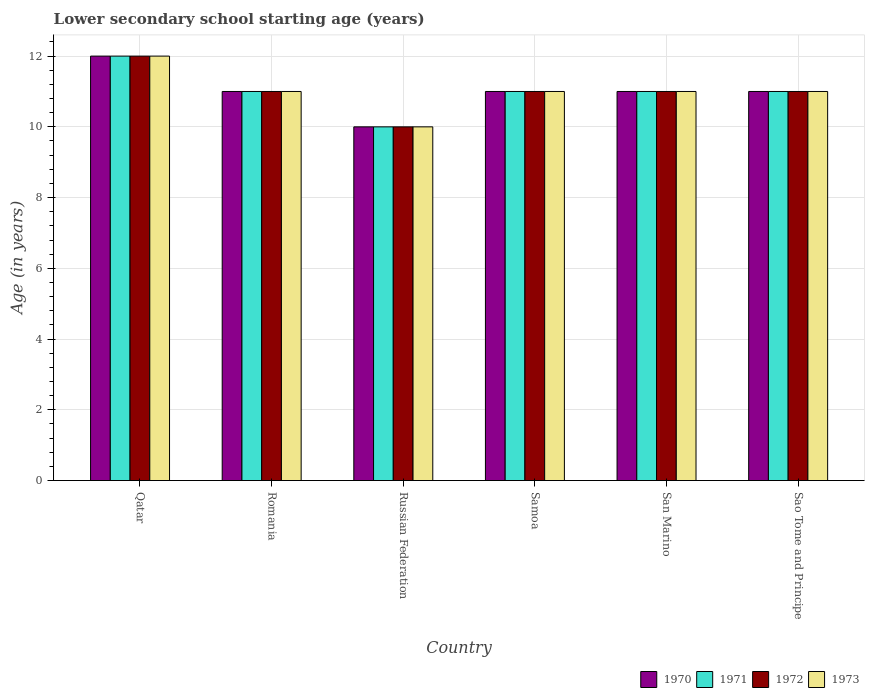How many different coloured bars are there?
Provide a short and direct response. 4. Are the number of bars per tick equal to the number of legend labels?
Keep it short and to the point. Yes. What is the label of the 6th group of bars from the left?
Your answer should be compact. Sao Tome and Principe. In how many cases, is the number of bars for a given country not equal to the number of legend labels?
Your answer should be compact. 0. In which country was the lower secondary school starting age of children in 1970 maximum?
Provide a short and direct response. Qatar. In which country was the lower secondary school starting age of children in 1971 minimum?
Give a very brief answer. Russian Federation. What is the total lower secondary school starting age of children in 1970 in the graph?
Make the answer very short. 66. What is the difference between the lower secondary school starting age of children in 1973 in Romania and that in San Marino?
Keep it short and to the point. 0. What is the difference between the lower secondary school starting age of children in 1970 in San Marino and the lower secondary school starting age of children in 1973 in Russian Federation?
Provide a succinct answer. 1. What is the difference between the lower secondary school starting age of children of/in 1973 and lower secondary school starting age of children of/in 1971 in Romania?
Ensure brevity in your answer.  0. In how many countries, is the lower secondary school starting age of children in 1970 greater than 6.8 years?
Keep it short and to the point. 6. What is the ratio of the lower secondary school starting age of children in 1970 in Qatar to that in Romania?
Offer a terse response. 1.09. Is it the case that in every country, the sum of the lower secondary school starting age of children in 1973 and lower secondary school starting age of children in 1972 is greater than the sum of lower secondary school starting age of children in 1970 and lower secondary school starting age of children in 1971?
Provide a succinct answer. No. Is it the case that in every country, the sum of the lower secondary school starting age of children in 1972 and lower secondary school starting age of children in 1970 is greater than the lower secondary school starting age of children in 1973?
Your answer should be very brief. Yes. Are all the bars in the graph horizontal?
Your answer should be very brief. No. How many countries are there in the graph?
Offer a terse response. 6. Where does the legend appear in the graph?
Ensure brevity in your answer.  Bottom right. How many legend labels are there?
Provide a short and direct response. 4. What is the title of the graph?
Your response must be concise. Lower secondary school starting age (years). What is the label or title of the Y-axis?
Make the answer very short. Age (in years). What is the Age (in years) of 1970 in Qatar?
Provide a short and direct response. 12. What is the Age (in years) of 1973 in Romania?
Your answer should be compact. 11. What is the Age (in years) of 1971 in Russian Federation?
Keep it short and to the point. 10. What is the Age (in years) of 1972 in Russian Federation?
Provide a succinct answer. 10. What is the Age (in years) of 1970 in Samoa?
Your response must be concise. 11. What is the Age (in years) of 1972 in Samoa?
Your answer should be very brief. 11. What is the Age (in years) of 1971 in Sao Tome and Principe?
Keep it short and to the point. 11. What is the Age (in years) of 1972 in Sao Tome and Principe?
Give a very brief answer. 11. Across all countries, what is the maximum Age (in years) in 1970?
Provide a short and direct response. 12. Across all countries, what is the minimum Age (in years) in 1970?
Your response must be concise. 10. Across all countries, what is the minimum Age (in years) of 1971?
Offer a terse response. 10. Across all countries, what is the minimum Age (in years) in 1973?
Ensure brevity in your answer.  10. What is the total Age (in years) of 1971 in the graph?
Your answer should be compact. 66. What is the difference between the Age (in years) in 1971 in Qatar and that in Romania?
Give a very brief answer. 1. What is the difference between the Age (in years) in 1973 in Qatar and that in Romania?
Ensure brevity in your answer.  1. What is the difference between the Age (in years) of 1970 in Qatar and that in Russian Federation?
Provide a succinct answer. 2. What is the difference between the Age (in years) of 1971 in Qatar and that in Russian Federation?
Give a very brief answer. 2. What is the difference between the Age (in years) of 1972 in Qatar and that in Samoa?
Make the answer very short. 1. What is the difference between the Age (in years) of 1973 in Qatar and that in Samoa?
Keep it short and to the point. 1. What is the difference between the Age (in years) of 1972 in Qatar and that in San Marino?
Give a very brief answer. 1. What is the difference between the Age (in years) in 1970 in Qatar and that in Sao Tome and Principe?
Offer a very short reply. 1. What is the difference between the Age (in years) of 1971 in Qatar and that in Sao Tome and Principe?
Your answer should be compact. 1. What is the difference between the Age (in years) of 1970 in Romania and that in Samoa?
Make the answer very short. 0. What is the difference between the Age (in years) in 1972 in Romania and that in Samoa?
Offer a terse response. 0. What is the difference between the Age (in years) of 1971 in Romania and that in San Marino?
Ensure brevity in your answer.  0. What is the difference between the Age (in years) in 1973 in Romania and that in San Marino?
Offer a very short reply. 0. What is the difference between the Age (in years) of 1971 in Romania and that in Sao Tome and Principe?
Offer a very short reply. 0. What is the difference between the Age (in years) in 1973 in Romania and that in Sao Tome and Principe?
Ensure brevity in your answer.  0. What is the difference between the Age (in years) of 1971 in Russian Federation and that in Samoa?
Your answer should be compact. -1. What is the difference between the Age (in years) of 1973 in Russian Federation and that in Samoa?
Provide a succinct answer. -1. What is the difference between the Age (in years) in 1971 in Russian Federation and that in San Marino?
Offer a very short reply. -1. What is the difference between the Age (in years) of 1970 in Russian Federation and that in Sao Tome and Principe?
Your answer should be compact. -1. What is the difference between the Age (in years) in 1972 in Russian Federation and that in Sao Tome and Principe?
Give a very brief answer. -1. What is the difference between the Age (in years) of 1971 in Samoa and that in San Marino?
Provide a short and direct response. 0. What is the difference between the Age (in years) in 1973 in Samoa and that in San Marino?
Your response must be concise. 0. What is the difference between the Age (in years) in 1970 in Samoa and that in Sao Tome and Principe?
Your response must be concise. 0. What is the difference between the Age (in years) of 1972 in Samoa and that in Sao Tome and Principe?
Your response must be concise. 0. What is the difference between the Age (in years) of 1973 in Samoa and that in Sao Tome and Principe?
Make the answer very short. 0. What is the difference between the Age (in years) in 1972 in San Marino and that in Sao Tome and Principe?
Make the answer very short. 0. What is the difference between the Age (in years) of 1971 in Qatar and the Age (in years) of 1972 in Romania?
Your response must be concise. 1. What is the difference between the Age (in years) of 1971 in Qatar and the Age (in years) of 1973 in Romania?
Provide a succinct answer. 1. What is the difference between the Age (in years) in 1970 in Qatar and the Age (in years) in 1971 in Russian Federation?
Your answer should be very brief. 2. What is the difference between the Age (in years) in 1970 in Qatar and the Age (in years) in 1972 in Russian Federation?
Your answer should be compact. 2. What is the difference between the Age (in years) of 1970 in Qatar and the Age (in years) of 1973 in Russian Federation?
Keep it short and to the point. 2. What is the difference between the Age (in years) in 1971 in Qatar and the Age (in years) in 1972 in Russian Federation?
Give a very brief answer. 2. What is the difference between the Age (in years) in 1971 in Qatar and the Age (in years) in 1973 in Russian Federation?
Your response must be concise. 2. What is the difference between the Age (in years) in 1970 in Qatar and the Age (in years) in 1972 in Samoa?
Provide a short and direct response. 1. What is the difference between the Age (in years) of 1970 in Qatar and the Age (in years) of 1973 in Samoa?
Ensure brevity in your answer.  1. What is the difference between the Age (in years) in 1971 in Qatar and the Age (in years) in 1972 in San Marino?
Offer a very short reply. 1. What is the difference between the Age (in years) of 1971 in Qatar and the Age (in years) of 1973 in San Marino?
Your response must be concise. 1. What is the difference between the Age (in years) of 1972 in Qatar and the Age (in years) of 1973 in San Marino?
Make the answer very short. 1. What is the difference between the Age (in years) of 1970 in Qatar and the Age (in years) of 1971 in Sao Tome and Principe?
Offer a very short reply. 1. What is the difference between the Age (in years) in 1970 in Qatar and the Age (in years) in 1972 in Sao Tome and Principe?
Offer a very short reply. 1. What is the difference between the Age (in years) of 1971 in Qatar and the Age (in years) of 1972 in Sao Tome and Principe?
Provide a succinct answer. 1. What is the difference between the Age (in years) of 1971 in Qatar and the Age (in years) of 1973 in Sao Tome and Principe?
Keep it short and to the point. 1. What is the difference between the Age (in years) in 1970 in Romania and the Age (in years) in 1971 in Russian Federation?
Your answer should be very brief. 1. What is the difference between the Age (in years) of 1970 in Romania and the Age (in years) of 1973 in Russian Federation?
Provide a short and direct response. 1. What is the difference between the Age (in years) in 1971 in Romania and the Age (in years) in 1972 in Russian Federation?
Your answer should be very brief. 1. What is the difference between the Age (in years) of 1971 in Romania and the Age (in years) of 1973 in Russian Federation?
Provide a short and direct response. 1. What is the difference between the Age (in years) in 1972 in Romania and the Age (in years) in 1973 in Russian Federation?
Provide a short and direct response. 1. What is the difference between the Age (in years) of 1970 in Romania and the Age (in years) of 1972 in Samoa?
Make the answer very short. 0. What is the difference between the Age (in years) of 1970 in Romania and the Age (in years) of 1973 in Samoa?
Your answer should be very brief. 0. What is the difference between the Age (in years) in 1971 in Romania and the Age (in years) in 1973 in Samoa?
Provide a short and direct response. 0. What is the difference between the Age (in years) of 1972 in Romania and the Age (in years) of 1973 in Samoa?
Your response must be concise. 0. What is the difference between the Age (in years) of 1970 in Romania and the Age (in years) of 1971 in San Marino?
Your answer should be compact. 0. What is the difference between the Age (in years) of 1970 in Romania and the Age (in years) of 1972 in San Marino?
Make the answer very short. 0. What is the difference between the Age (in years) in 1972 in Romania and the Age (in years) in 1973 in San Marino?
Your response must be concise. 0. What is the difference between the Age (in years) in 1970 in Romania and the Age (in years) in 1972 in Sao Tome and Principe?
Provide a short and direct response. 0. What is the difference between the Age (in years) of 1971 in Romania and the Age (in years) of 1972 in Sao Tome and Principe?
Your answer should be compact. 0. What is the difference between the Age (in years) of 1971 in Romania and the Age (in years) of 1973 in Sao Tome and Principe?
Ensure brevity in your answer.  0. What is the difference between the Age (in years) of 1972 in Romania and the Age (in years) of 1973 in Sao Tome and Principe?
Make the answer very short. 0. What is the difference between the Age (in years) of 1970 in Russian Federation and the Age (in years) of 1972 in Samoa?
Keep it short and to the point. -1. What is the difference between the Age (in years) of 1971 in Russian Federation and the Age (in years) of 1973 in Samoa?
Make the answer very short. -1. What is the difference between the Age (in years) of 1970 in Russian Federation and the Age (in years) of 1971 in San Marino?
Provide a short and direct response. -1. What is the difference between the Age (in years) in 1971 in Russian Federation and the Age (in years) in 1972 in San Marino?
Keep it short and to the point. -1. What is the difference between the Age (in years) in 1972 in Russian Federation and the Age (in years) in 1973 in San Marino?
Your response must be concise. -1. What is the difference between the Age (in years) of 1970 in Russian Federation and the Age (in years) of 1972 in Sao Tome and Principe?
Your answer should be very brief. -1. What is the difference between the Age (in years) of 1970 in Russian Federation and the Age (in years) of 1973 in Sao Tome and Principe?
Offer a terse response. -1. What is the difference between the Age (in years) of 1971 in Russian Federation and the Age (in years) of 1972 in Sao Tome and Principe?
Your answer should be very brief. -1. What is the difference between the Age (in years) in 1972 in Russian Federation and the Age (in years) in 1973 in Sao Tome and Principe?
Provide a succinct answer. -1. What is the difference between the Age (in years) of 1970 in Samoa and the Age (in years) of 1973 in San Marino?
Offer a terse response. 0. What is the difference between the Age (in years) of 1971 in Samoa and the Age (in years) of 1972 in San Marino?
Your answer should be compact. 0. What is the difference between the Age (in years) in 1972 in Samoa and the Age (in years) in 1973 in San Marino?
Give a very brief answer. 0. What is the difference between the Age (in years) of 1970 in Samoa and the Age (in years) of 1971 in Sao Tome and Principe?
Provide a succinct answer. 0. What is the difference between the Age (in years) of 1970 in Samoa and the Age (in years) of 1972 in Sao Tome and Principe?
Provide a succinct answer. 0. What is the difference between the Age (in years) in 1970 in Samoa and the Age (in years) in 1973 in Sao Tome and Principe?
Provide a succinct answer. 0. What is the difference between the Age (in years) of 1972 in Samoa and the Age (in years) of 1973 in Sao Tome and Principe?
Provide a succinct answer. 0. What is the difference between the Age (in years) in 1970 in San Marino and the Age (in years) in 1971 in Sao Tome and Principe?
Keep it short and to the point. 0. What is the difference between the Age (in years) in 1970 in San Marino and the Age (in years) in 1972 in Sao Tome and Principe?
Offer a terse response. 0. What is the difference between the Age (in years) in 1972 in San Marino and the Age (in years) in 1973 in Sao Tome and Principe?
Keep it short and to the point. 0. What is the average Age (in years) in 1970 per country?
Your response must be concise. 11. What is the difference between the Age (in years) of 1971 and Age (in years) of 1972 in Qatar?
Offer a terse response. 0. What is the difference between the Age (in years) in 1970 and Age (in years) in 1971 in Romania?
Provide a succinct answer. 0. What is the difference between the Age (in years) of 1970 and Age (in years) of 1973 in Romania?
Your response must be concise. 0. What is the difference between the Age (in years) of 1971 and Age (in years) of 1972 in Romania?
Offer a very short reply. 0. What is the difference between the Age (in years) of 1972 and Age (in years) of 1973 in Romania?
Your answer should be compact. 0. What is the difference between the Age (in years) of 1970 and Age (in years) of 1971 in Russian Federation?
Your answer should be compact. 0. What is the difference between the Age (in years) of 1970 and Age (in years) of 1973 in Russian Federation?
Your response must be concise. 0. What is the difference between the Age (in years) in 1970 and Age (in years) in 1971 in Samoa?
Provide a succinct answer. 0. What is the difference between the Age (in years) in 1970 and Age (in years) in 1972 in Samoa?
Your answer should be compact. 0. What is the difference between the Age (in years) in 1971 and Age (in years) in 1972 in Samoa?
Ensure brevity in your answer.  0. What is the difference between the Age (in years) in 1971 and Age (in years) in 1973 in Samoa?
Your response must be concise. 0. What is the difference between the Age (in years) in 1972 and Age (in years) in 1973 in Samoa?
Provide a short and direct response. 0. What is the difference between the Age (in years) in 1970 and Age (in years) in 1971 in San Marino?
Provide a succinct answer. 0. What is the difference between the Age (in years) in 1970 and Age (in years) in 1973 in San Marino?
Ensure brevity in your answer.  0. What is the difference between the Age (in years) in 1971 and Age (in years) in 1972 in San Marino?
Your answer should be very brief. 0. What is the difference between the Age (in years) in 1972 and Age (in years) in 1973 in San Marino?
Your answer should be compact. 0. What is the difference between the Age (in years) in 1970 and Age (in years) in 1972 in Sao Tome and Principe?
Keep it short and to the point. 0. What is the difference between the Age (in years) of 1970 and Age (in years) of 1973 in Sao Tome and Principe?
Offer a terse response. 0. What is the difference between the Age (in years) of 1971 and Age (in years) of 1972 in Sao Tome and Principe?
Ensure brevity in your answer.  0. What is the ratio of the Age (in years) in 1970 in Qatar to that in Romania?
Provide a short and direct response. 1.09. What is the ratio of the Age (in years) of 1972 in Qatar to that in Romania?
Offer a very short reply. 1.09. What is the ratio of the Age (in years) in 1973 in Qatar to that in Romania?
Your answer should be very brief. 1.09. What is the ratio of the Age (in years) of 1972 in Qatar to that in Russian Federation?
Ensure brevity in your answer.  1.2. What is the ratio of the Age (in years) in 1973 in Qatar to that in Russian Federation?
Provide a short and direct response. 1.2. What is the ratio of the Age (in years) in 1971 in Qatar to that in Samoa?
Make the answer very short. 1.09. What is the ratio of the Age (in years) in 1972 in Qatar to that in Samoa?
Provide a succinct answer. 1.09. What is the ratio of the Age (in years) of 1973 in Qatar to that in Samoa?
Provide a short and direct response. 1.09. What is the ratio of the Age (in years) in 1970 in Qatar to that in San Marino?
Give a very brief answer. 1.09. What is the ratio of the Age (in years) of 1971 in Qatar to that in San Marino?
Keep it short and to the point. 1.09. What is the ratio of the Age (in years) in 1972 in Qatar to that in San Marino?
Make the answer very short. 1.09. What is the ratio of the Age (in years) of 1971 in Qatar to that in Sao Tome and Principe?
Offer a very short reply. 1.09. What is the ratio of the Age (in years) in 1972 in Qatar to that in Sao Tome and Principe?
Keep it short and to the point. 1.09. What is the ratio of the Age (in years) of 1970 in Romania to that in Russian Federation?
Ensure brevity in your answer.  1.1. What is the ratio of the Age (in years) in 1971 in Romania to that in Russian Federation?
Offer a terse response. 1.1. What is the ratio of the Age (in years) of 1973 in Romania to that in Russian Federation?
Keep it short and to the point. 1.1. What is the ratio of the Age (in years) in 1970 in Romania to that in Samoa?
Keep it short and to the point. 1. What is the ratio of the Age (in years) of 1972 in Romania to that in Samoa?
Keep it short and to the point. 1. What is the ratio of the Age (in years) of 1973 in Romania to that in San Marino?
Offer a terse response. 1. What is the ratio of the Age (in years) of 1970 in Romania to that in Sao Tome and Principe?
Offer a very short reply. 1. What is the ratio of the Age (in years) in 1972 in Romania to that in Sao Tome and Principe?
Offer a very short reply. 1. What is the ratio of the Age (in years) in 1973 in Russian Federation to that in Samoa?
Provide a succinct answer. 0.91. What is the ratio of the Age (in years) of 1970 in Russian Federation to that in San Marino?
Offer a terse response. 0.91. What is the ratio of the Age (in years) in 1972 in Russian Federation to that in Sao Tome and Principe?
Make the answer very short. 0.91. What is the ratio of the Age (in years) of 1971 in Samoa to that in San Marino?
Ensure brevity in your answer.  1. What is the ratio of the Age (in years) in 1970 in Samoa to that in Sao Tome and Principe?
Make the answer very short. 1. What is the ratio of the Age (in years) in 1972 in Samoa to that in Sao Tome and Principe?
Keep it short and to the point. 1. What is the ratio of the Age (in years) in 1972 in San Marino to that in Sao Tome and Principe?
Give a very brief answer. 1. What is the difference between the highest and the second highest Age (in years) of 1970?
Offer a very short reply. 1. What is the difference between the highest and the second highest Age (in years) in 1972?
Make the answer very short. 1. What is the difference between the highest and the lowest Age (in years) of 1971?
Your answer should be very brief. 2. 